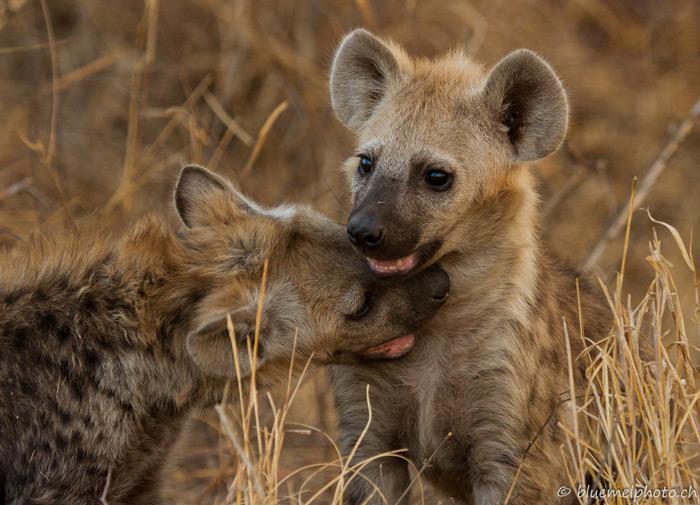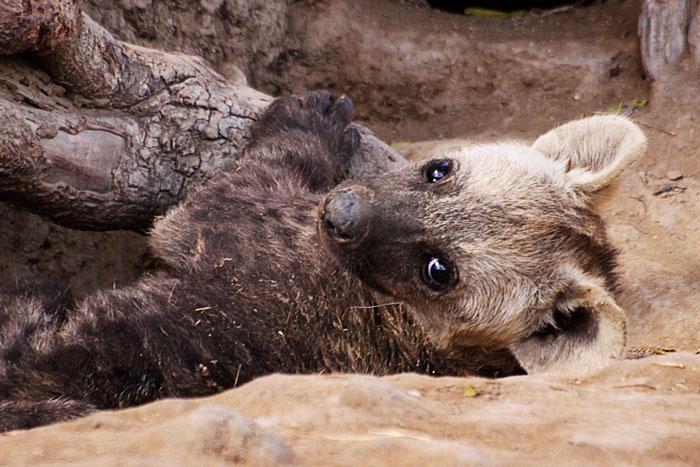The first image is the image on the left, the second image is the image on the right. Assess this claim about the two images: "One standing animal with a black nose is looking forward in the right image.". Correct or not? Answer yes or no. No. The first image is the image on the left, the second image is the image on the right. Evaluate the accuracy of this statement regarding the images: "The image on the left shows 2 animals both looking in the same direction.". Is it true? Answer yes or no. No. 